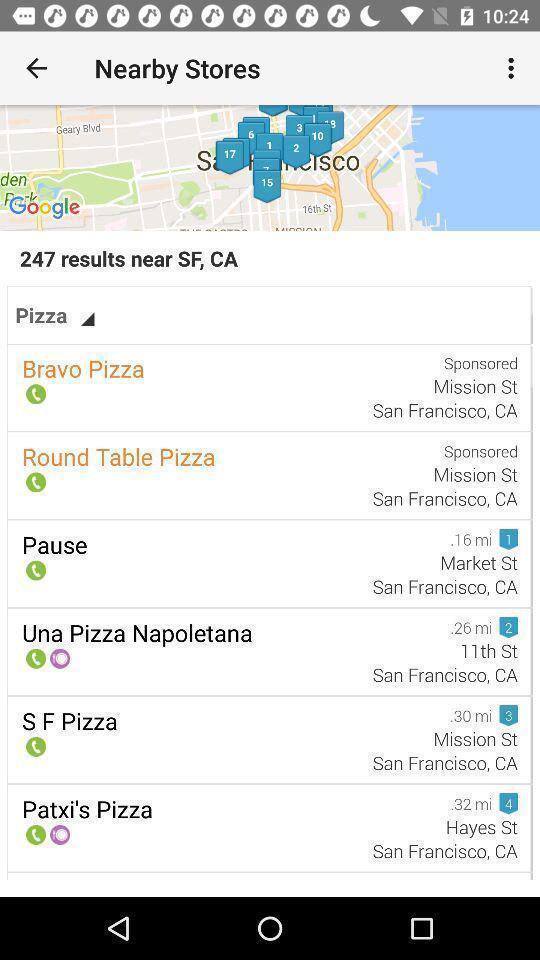Describe the content in this image. Pizza stores page in an online app. 